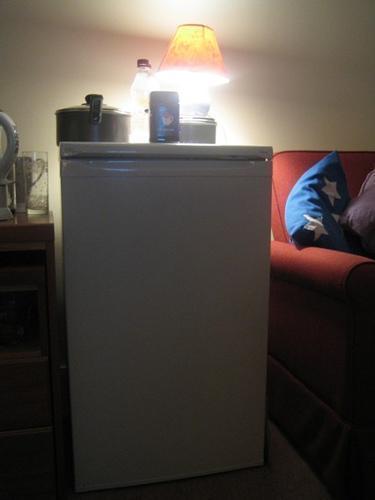How many pink umbrellas are there?
Give a very brief answer. 0. 